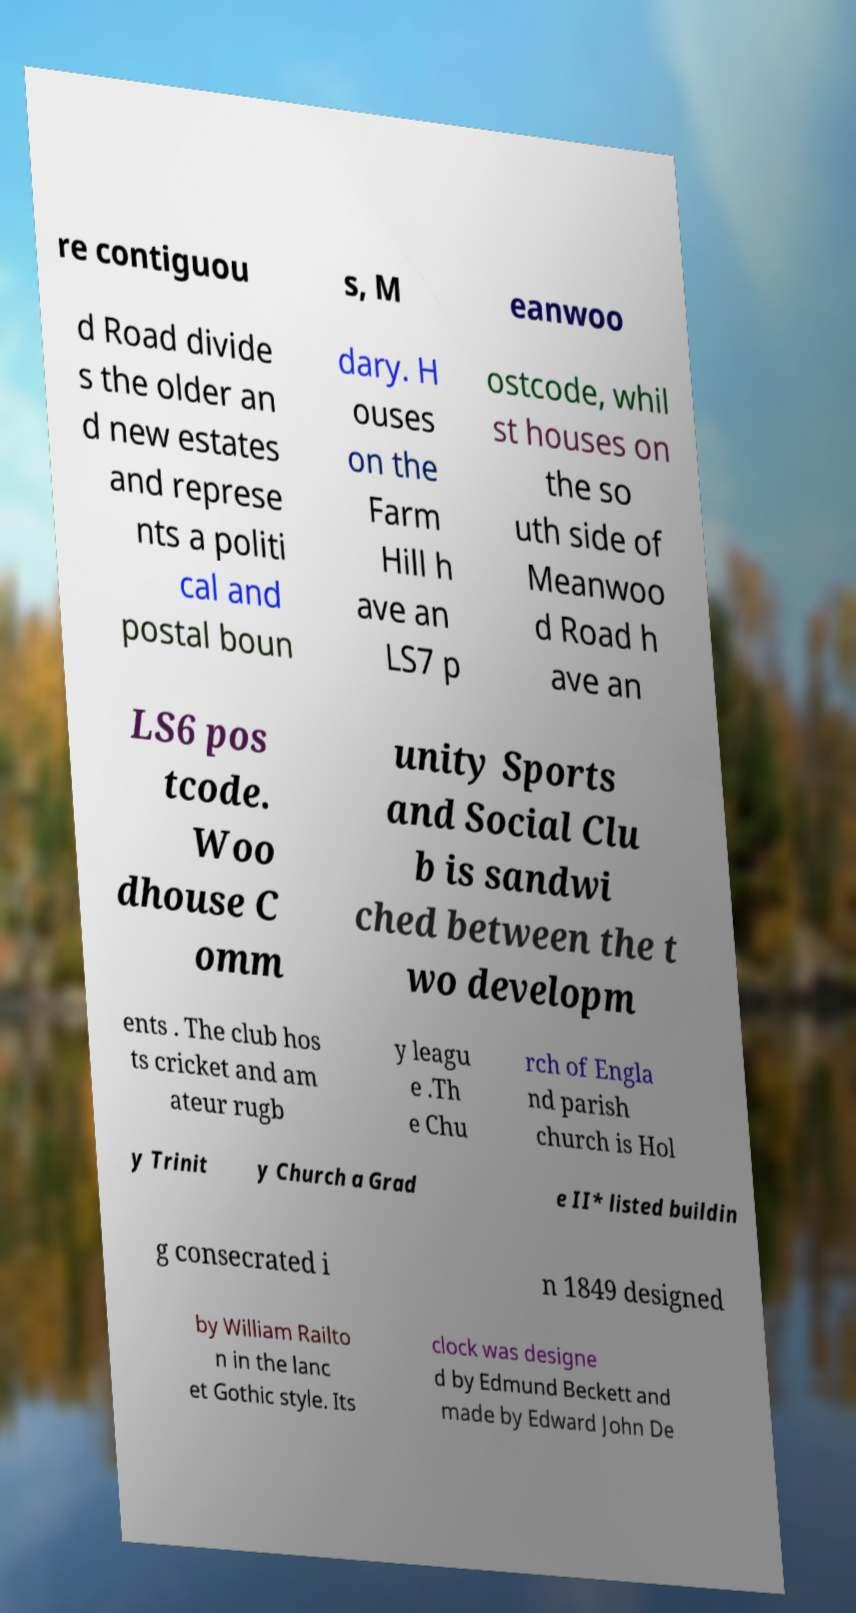There's text embedded in this image that I need extracted. Can you transcribe it verbatim? re contiguou s, M eanwoo d Road divide s the older an d new estates and represe nts a politi cal and postal boun dary. H ouses on the Farm Hill h ave an LS7 p ostcode, whil st houses on the so uth side of Meanwoo d Road h ave an LS6 pos tcode. Woo dhouse C omm unity Sports and Social Clu b is sandwi ched between the t wo developm ents . The club hos ts cricket and am ateur rugb y leagu e .Th e Chu rch of Engla nd parish church is Hol y Trinit y Church a Grad e II* listed buildin g consecrated i n 1849 designed by William Railto n in the lanc et Gothic style. Its clock was designe d by Edmund Beckett and made by Edward John De 